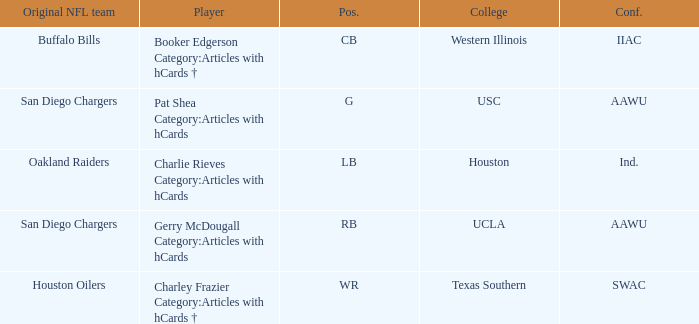What player's original team are the Oakland Raiders? Charlie Rieves Category:Articles with hCards. 